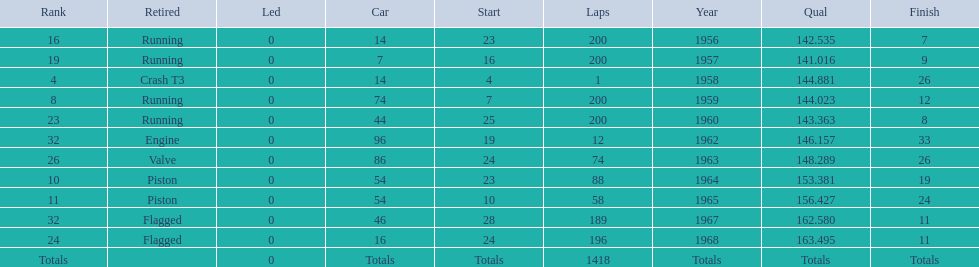What year did he have the same number car as 1964? 1965. 